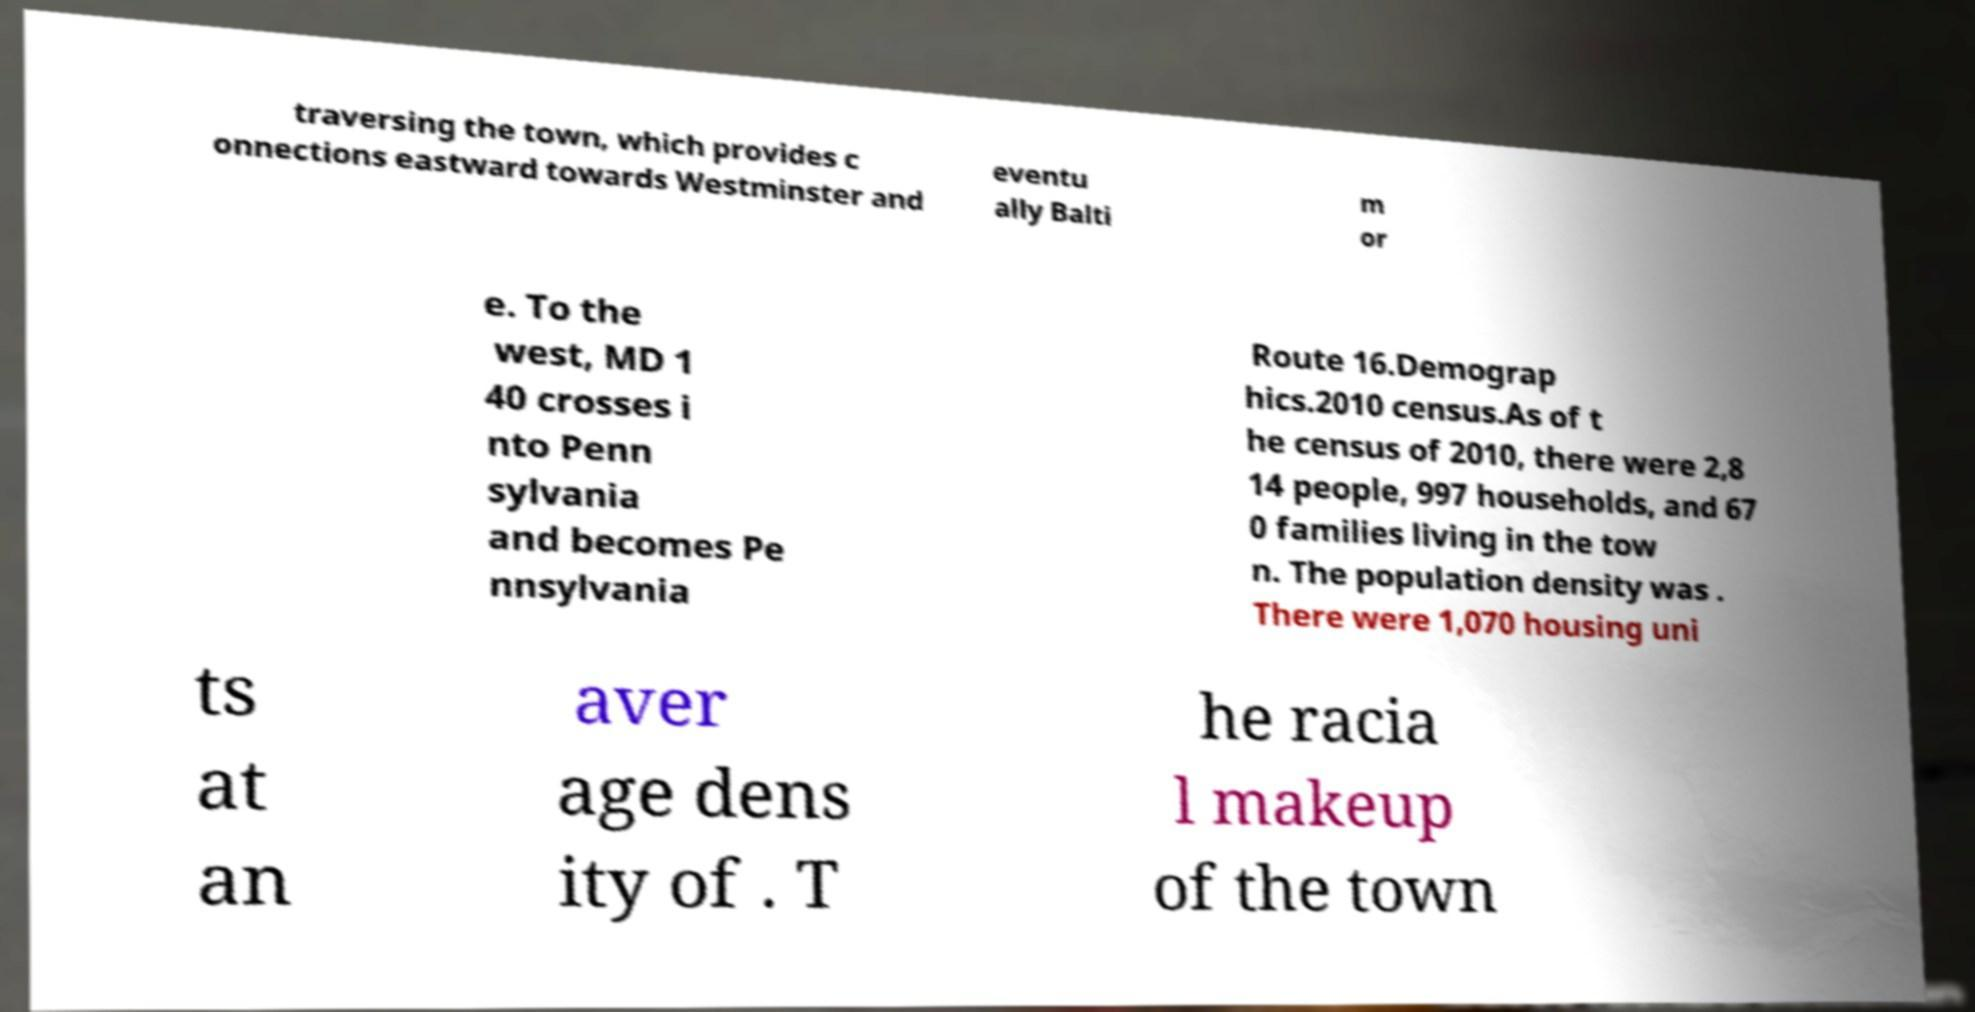Can you accurately transcribe the text from the provided image for me? traversing the town, which provides c onnections eastward towards Westminster and eventu ally Balti m or e. To the west, MD 1 40 crosses i nto Penn sylvania and becomes Pe nnsylvania Route 16.Demograp hics.2010 census.As of t he census of 2010, there were 2,8 14 people, 997 households, and 67 0 families living in the tow n. The population density was . There were 1,070 housing uni ts at an aver age dens ity of . T he racia l makeup of the town 